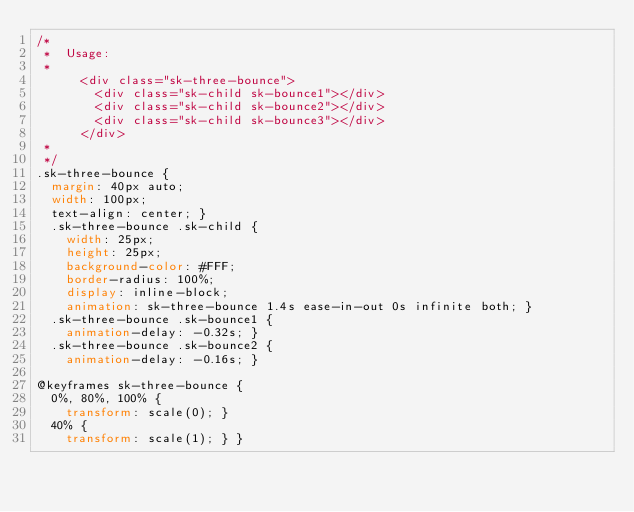Convert code to text. <code><loc_0><loc_0><loc_500><loc_500><_CSS_>/*
 *  Usage:
 *
      <div class="sk-three-bounce">
        <div class="sk-child sk-bounce1"></div>
        <div class="sk-child sk-bounce2"></div>
        <div class="sk-child sk-bounce3"></div>
      </div>
 *
 */
.sk-three-bounce {
  margin: 40px auto;
  width: 100px;
  text-align: center; }
  .sk-three-bounce .sk-child {
    width: 25px;
    height: 25px;
    background-color: #FFF;
    border-radius: 100%;
    display: inline-block;
    animation: sk-three-bounce 1.4s ease-in-out 0s infinite both; }
  .sk-three-bounce .sk-bounce1 {
    animation-delay: -0.32s; }
  .sk-three-bounce .sk-bounce2 {
    animation-delay: -0.16s; }

@keyframes sk-three-bounce {
  0%, 80%, 100% {
    transform: scale(0); }
  40% {
    transform: scale(1); } }
</code> 